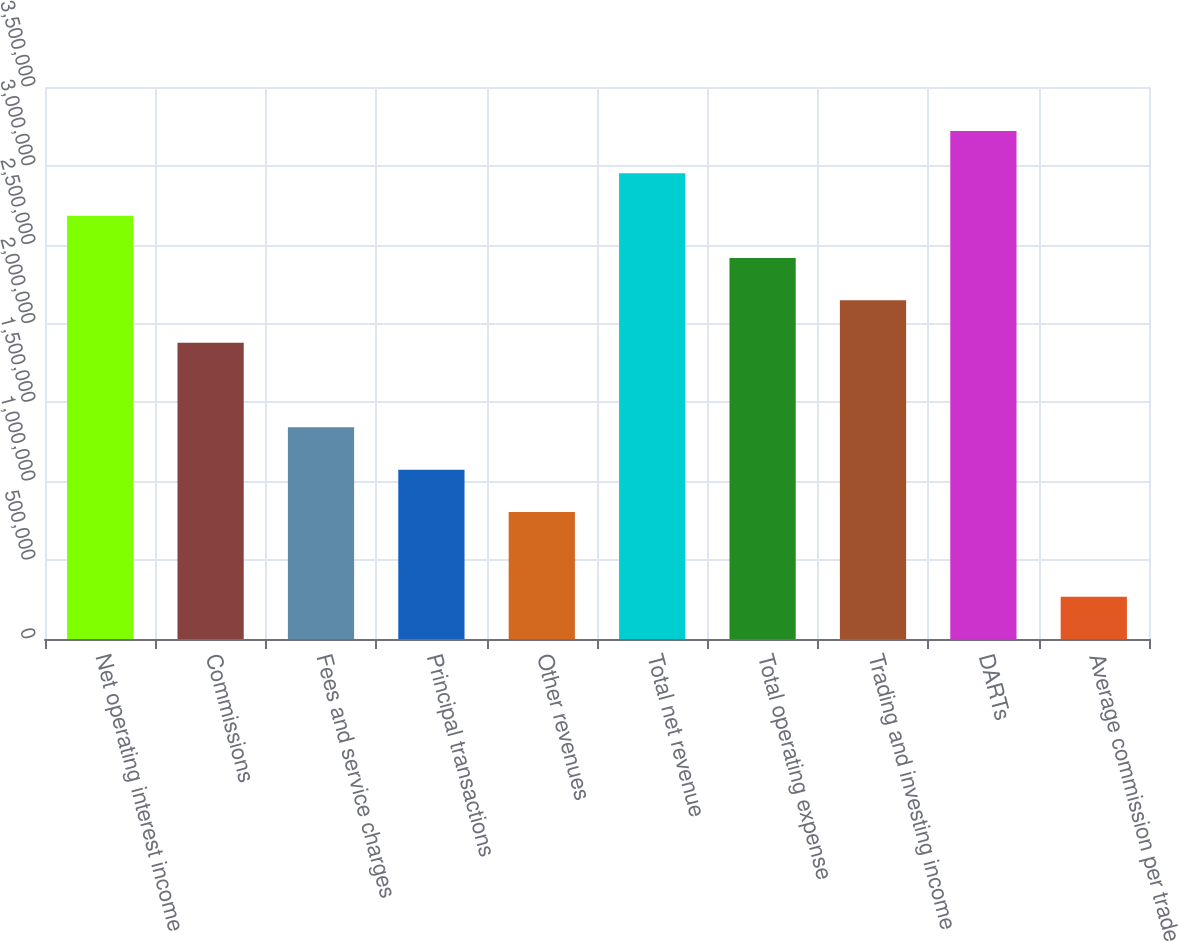Convert chart. <chart><loc_0><loc_0><loc_500><loc_500><bar_chart><fcel>Net operating interest income<fcel>Commissions<fcel>Fees and service charges<fcel>Principal transactions<fcel>Other revenues<fcel>Total net revenue<fcel>Total operating expense<fcel>Trading and investing income<fcel>DARTs<fcel>Average commission per trade<nl><fcel>2.68431e+06<fcel>1.87902e+06<fcel>1.34216e+06<fcel>1.07373e+06<fcel>805297<fcel>2.95274e+06<fcel>2.41588e+06<fcel>2.14745e+06<fcel>3.22117e+06<fcel>268436<nl></chart> 